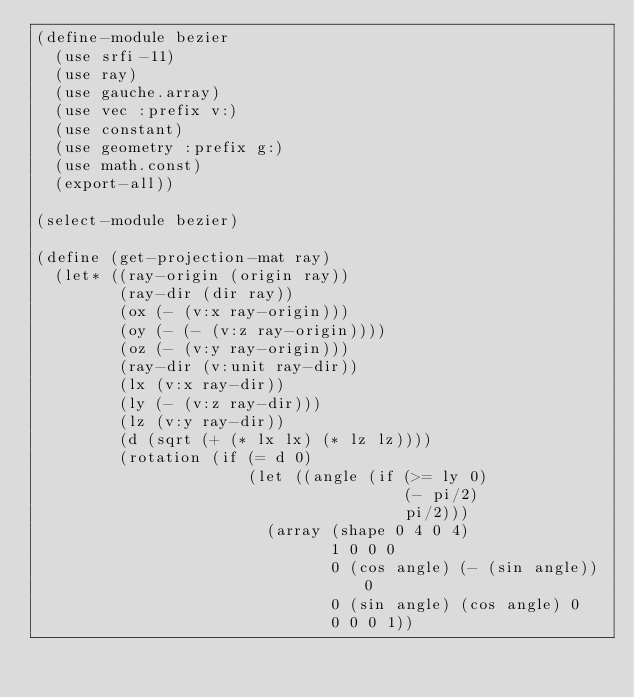Convert code to text. <code><loc_0><loc_0><loc_500><loc_500><_Scheme_>(define-module bezier
  (use srfi-11)
  (use ray)
  (use gauche.array)
  (use vec :prefix v:)
  (use constant)
  (use geometry :prefix g:)
  (use math.const)
  (export-all))

(select-module bezier)

(define (get-projection-mat ray)
  (let* ((ray-origin (origin ray))
         (ray-dir (dir ray))
         (ox (- (v:x ray-origin)))
         (oy (- (- (v:z ray-origin))))
         (oz (- (v:y ray-origin)))
         (ray-dir (v:unit ray-dir))
         (lx (v:x ray-dir))
         (ly (- (v:z ray-dir)))
         (lz (v:y ray-dir))
         (d (sqrt (+ (* lx lx) (* lz lz))))
         (rotation (if (= d 0)
                       (let ((angle (if (>= ly 0)
                                        (- pi/2)
                                        pi/2)))
                         (array (shape 0 4 0 4)
                                1 0 0 0
                                0 (cos angle) (- (sin angle)) 0
                                0 (sin angle) (cos angle) 0
                                0 0 0 1))</code> 